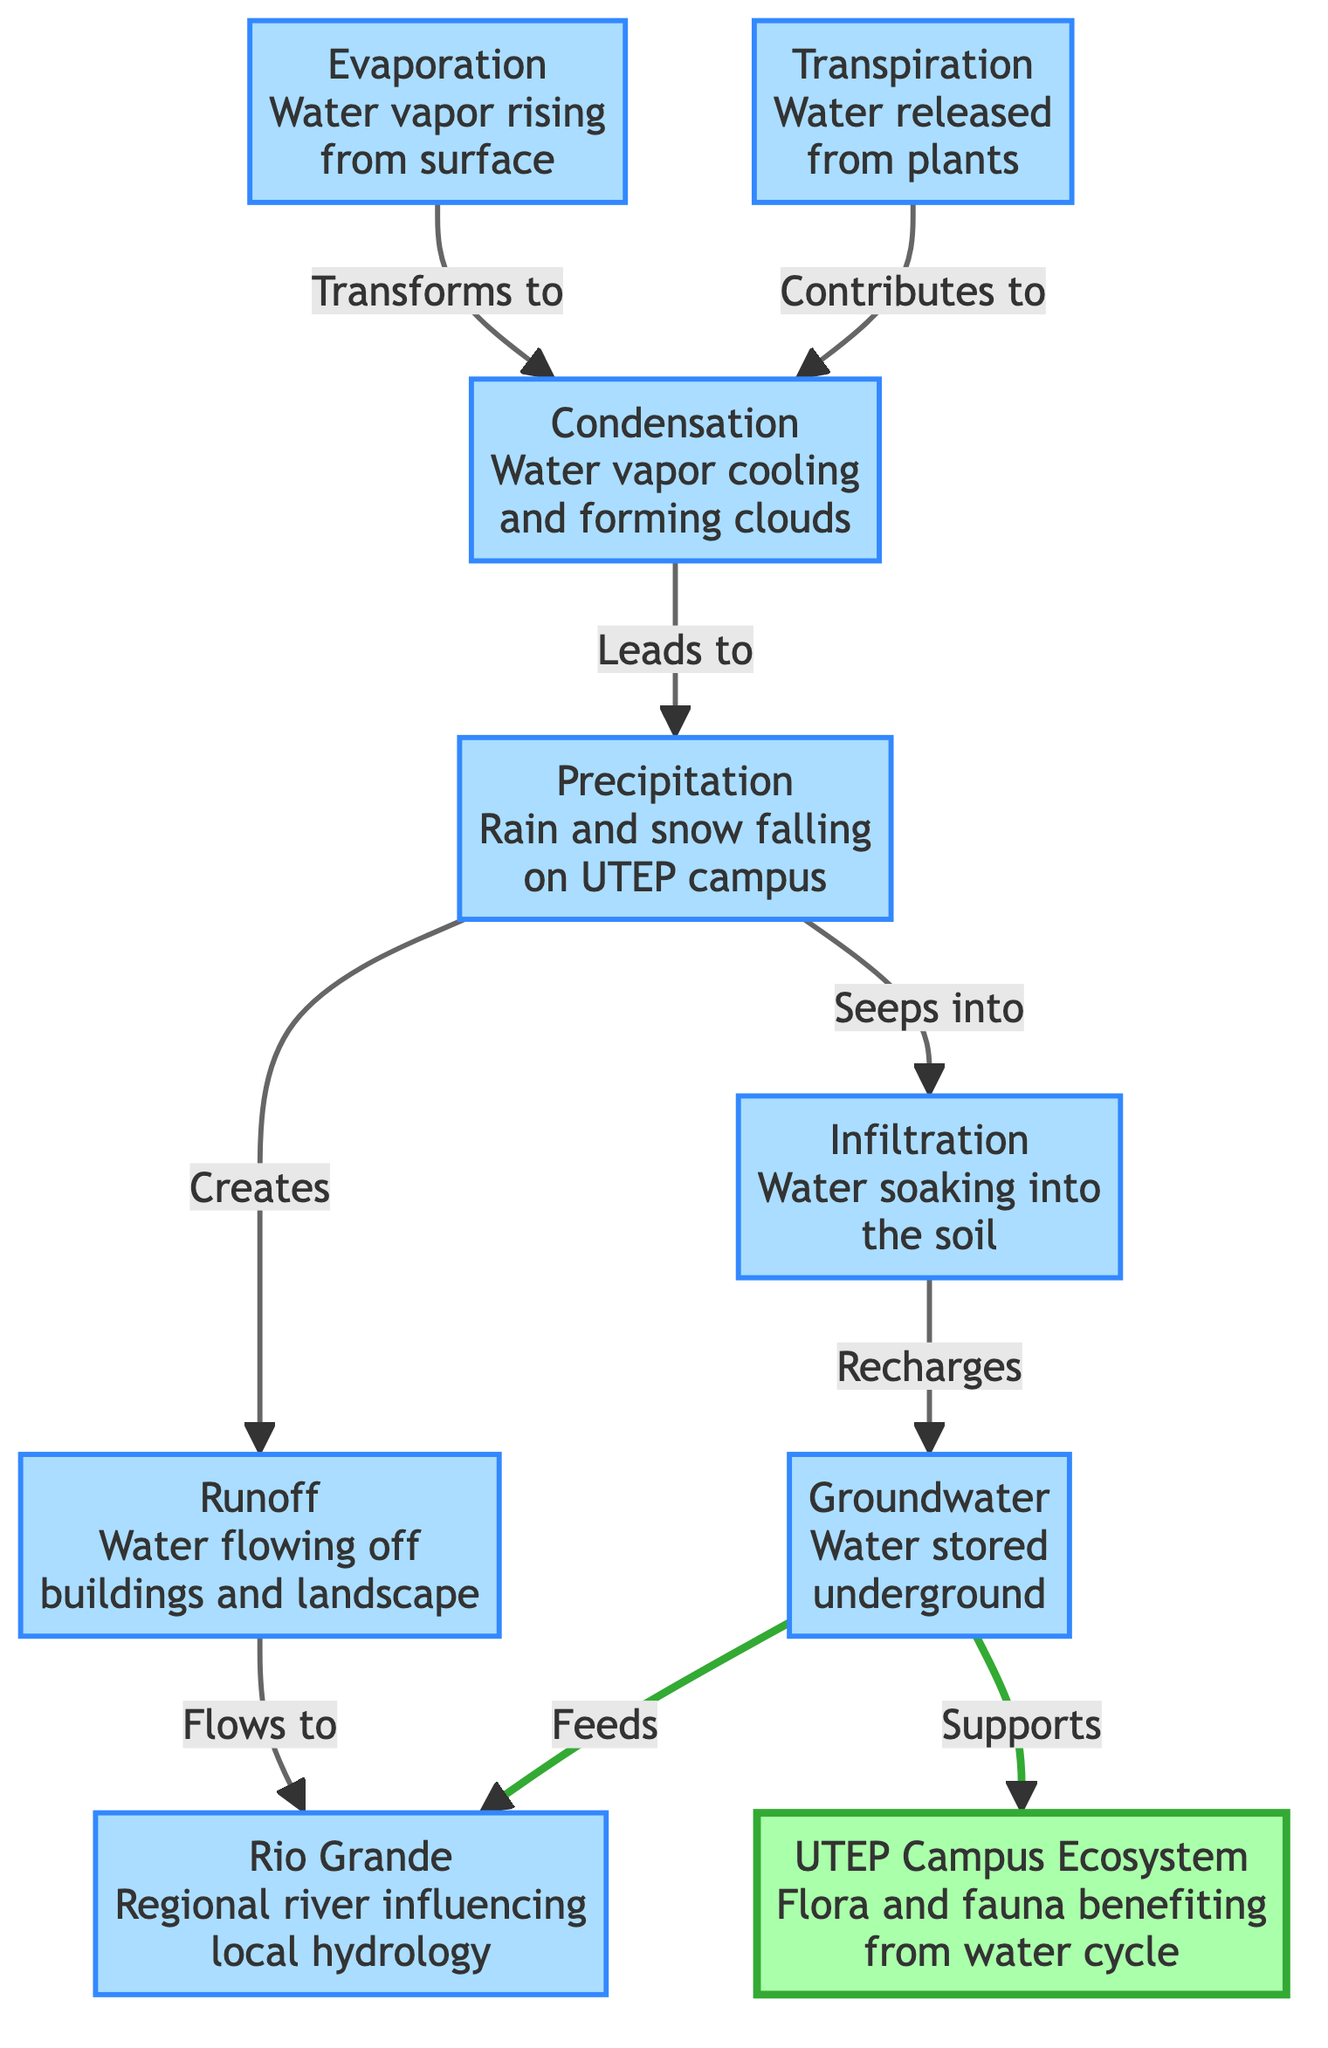What is the primary source of water that falls on UTEP campus? The diagram indicates "Precipitation" as the source where rain and snow falls onto the campus. This node is specifically labeled and serves as the starting point of the water cycle on campus.
Answer: Precipitation How many nodes are there in the water cycle diagram? By counting each distinct labeled element in the diagram, we identify a total of eight nodes, which represent various processes or components of the water cycle.
Answer: 8 What process follows evaporation in the water cycle? The diagram shows that evaporation leads to condensation. This indicates that after water vapor rises, it cools and forms clouds, which is the next step in the cycle.
Answer: Condensation What does groundwater support in the ecosystem? The diagram clearly states that groundwater "Supports" the "UTEP Campus Ecosystem." This reveals the importance of groundwater in providing necessary resources to flora and fauna on campus.
Answer: Ecosystem Which process contributes to the formation of clouds? According to the diagram, both evaporation and transpiration contribute to condensation, which is the process that leads to cloud formation. This relationship shows the interconnectedness of these processes.
Answer: Evaporation and Transpiration How does runoff from the UTEP campus affect the Rio Grande? The diagram indicates that runoff flows to the Rio Grande, highlighting a direct connection and impact of the campus's water management on the regional hydrology system.
Answer: Flows to How does water move from infiltration to groundwater? The diagram specifies that infiltration involves water soaking into the soil, and this process directly "Recharges" groundwater, meaning that the water absorbed into the ground contributes to the underground water supply.
Answer: Recharges What is the role of precipitation in the water cycle? Precipitation serves as the initial step that creates runoff and seeps into the ground as infiltration, establishing its pivotal role in initiating various water processes on campus.
Answer: Creates Which node represents the regional river that influences local hydrology? The diagram marks the "Rio Grande" as the regional river, differentiating it as an external body of water impacting the water cycle in the UTEP campus ecosystem.
Answer: Rio Grande 